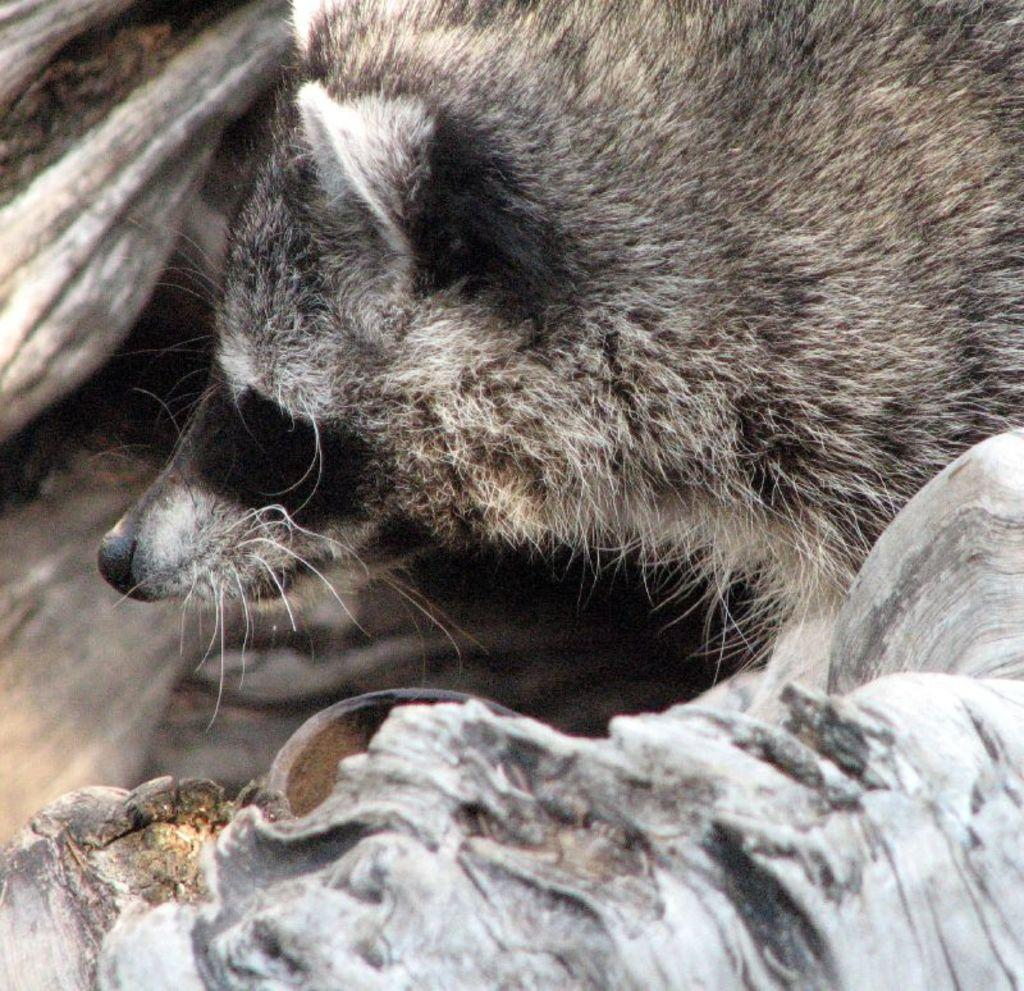What type of object is located at the bottom of the image? There is a wooden object at the bottom of the image. What other wooden object can be seen in the image? There is a wooden object resembling a tree trunk on the left side of the image. Can you describe the animal visible in the image? Unfortunately, the facts provided do not give enough information to describe the animal in the image. What type of fiction book is the giraffe reading in the image? There is no giraffe or book present in the image, so this question cannot be answered. 